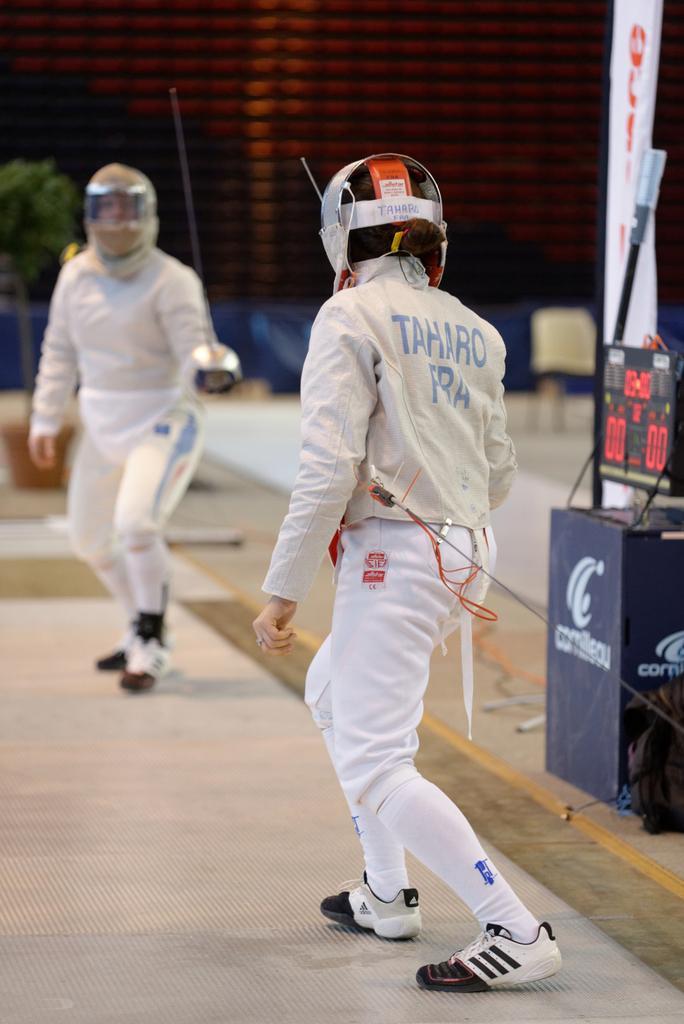Can you describe this image briefly? In this picture we can see few people, they are holding swords and they wore helmets, in the background we can see few plants and a hoarding. 